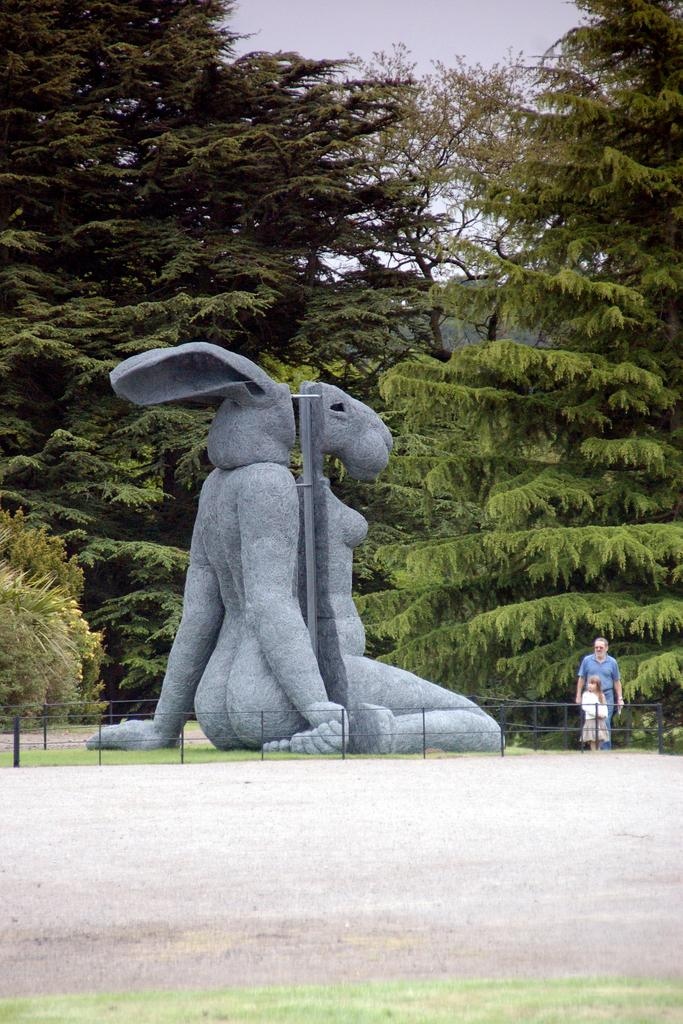What is the main feature of the image? There is a road in the image. Are there any other notable objects or structures in the image? Yes, there is a statue in the image. Can you describe the people in the image? There are two people on the right side of the image. What can be seen in the background of the image? There are trees and the sky visible in the background of the image. How many snails can be seen crawling on the statue in the image? There are no snails visible on the statue in the image. What type of property is being sold in the image? There is no indication of any property being sold in the image. 